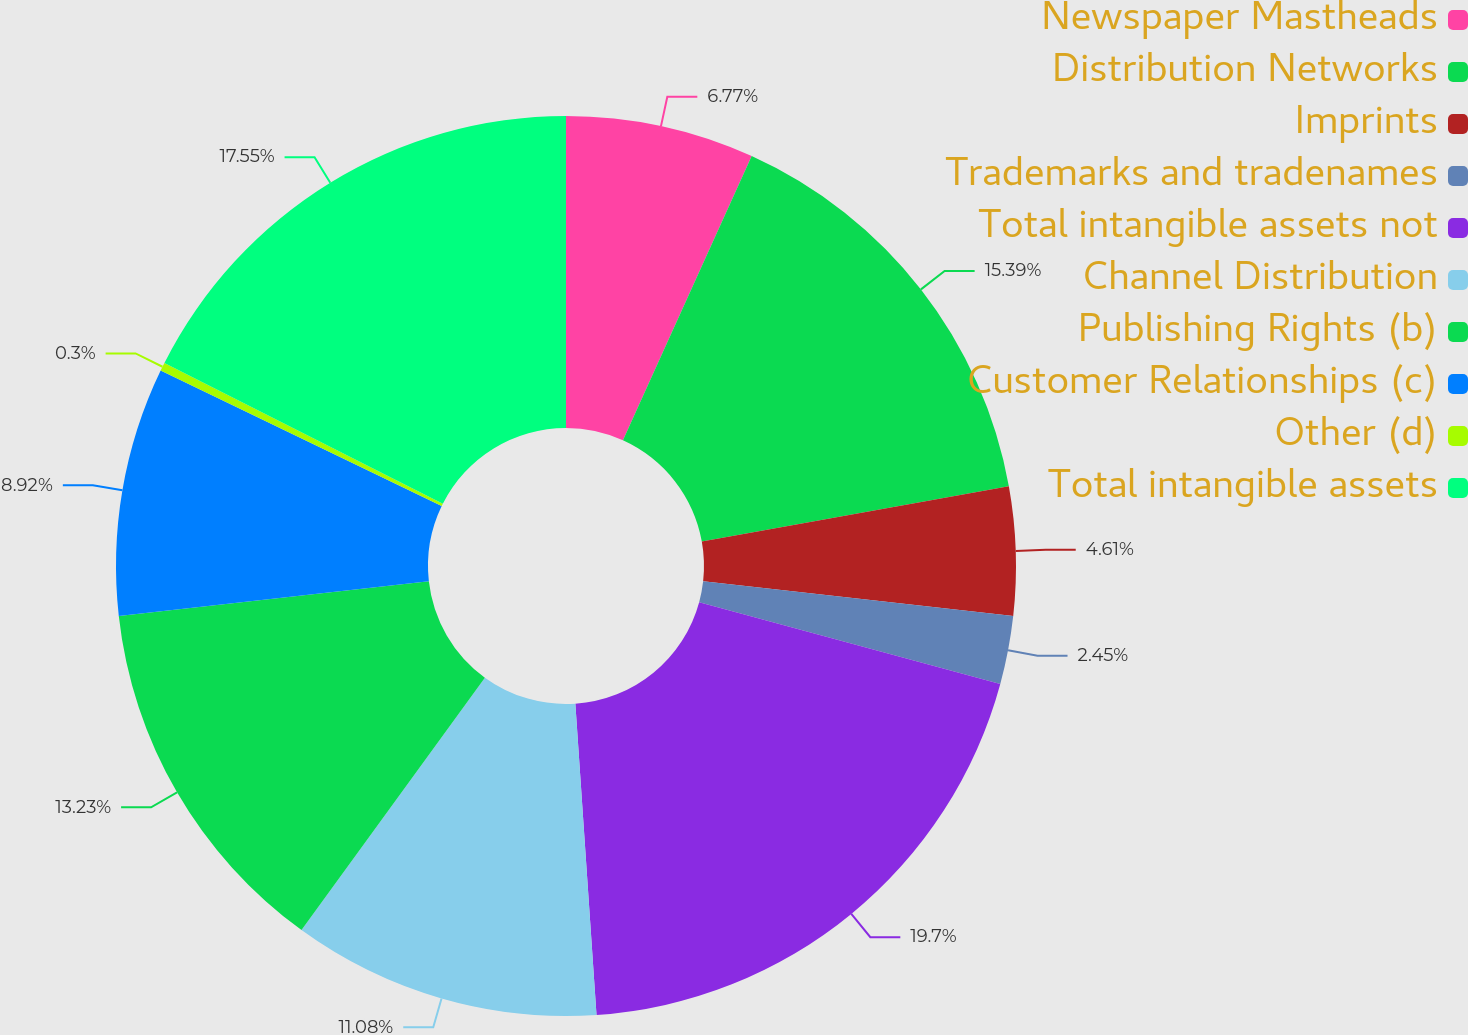Convert chart to OTSL. <chart><loc_0><loc_0><loc_500><loc_500><pie_chart><fcel>Newspaper Mastheads<fcel>Distribution Networks<fcel>Imprints<fcel>Trademarks and tradenames<fcel>Total intangible assets not<fcel>Channel Distribution<fcel>Publishing Rights (b)<fcel>Customer Relationships (c)<fcel>Other (d)<fcel>Total intangible assets<nl><fcel>6.77%<fcel>15.39%<fcel>4.61%<fcel>2.45%<fcel>19.7%<fcel>11.08%<fcel>13.23%<fcel>8.92%<fcel>0.3%<fcel>17.55%<nl></chart> 